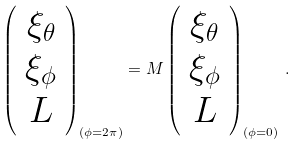<formula> <loc_0><loc_0><loc_500><loc_500>\left ( \begin{array} { c } \xi _ { \theta } \\ \xi _ { \phi } \\ L \end{array} \right ) _ { ( \phi = 2 \pi ) } = M \left ( \begin{array} { c } \xi _ { \theta } \\ \xi _ { \phi } \\ L \end{array} \right ) _ { ( \phi = 0 ) } \, .</formula> 